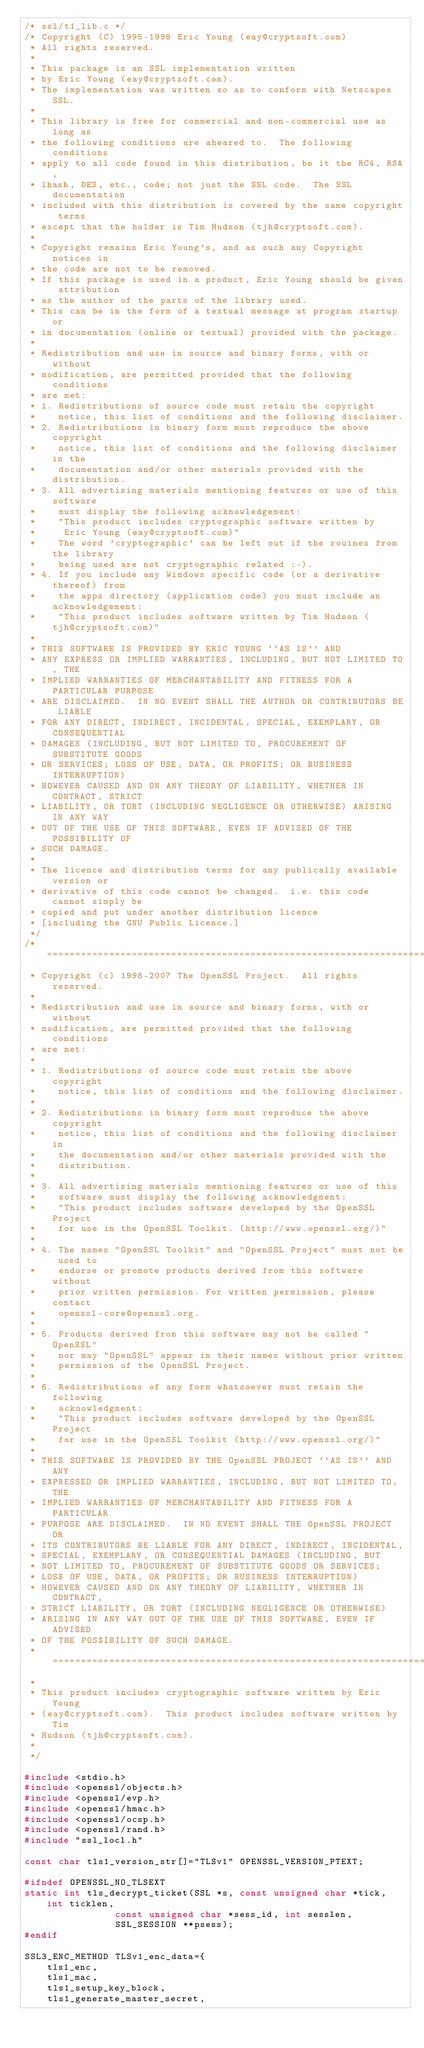Convert code to text. <code><loc_0><loc_0><loc_500><loc_500><_C_>/* ssl/t1_lib.c */
/* Copyright (C) 1995-1998 Eric Young (eay@cryptsoft.com)
 * All rights reserved.
 *
 * This package is an SSL implementation written
 * by Eric Young (eay@cryptsoft.com).
 * The implementation was written so as to conform with Netscapes SSL.
 * 
 * This library is free for commercial and non-commercial use as long as
 * the following conditions are aheared to.  The following conditions
 * apply to all code found in this distribution, be it the RC4, RSA,
 * lhash, DES, etc., code; not just the SSL code.  The SSL documentation
 * included with this distribution is covered by the same copyright terms
 * except that the holder is Tim Hudson (tjh@cryptsoft.com).
 * 
 * Copyright remains Eric Young's, and as such any Copyright notices in
 * the code are not to be removed.
 * If this package is used in a product, Eric Young should be given attribution
 * as the author of the parts of the library used.
 * This can be in the form of a textual message at program startup or
 * in documentation (online or textual) provided with the package.
 * 
 * Redistribution and use in source and binary forms, with or without
 * modification, are permitted provided that the following conditions
 * are met:
 * 1. Redistributions of source code must retain the copyright
 *    notice, this list of conditions and the following disclaimer.
 * 2. Redistributions in binary form must reproduce the above copyright
 *    notice, this list of conditions and the following disclaimer in the
 *    documentation and/or other materials provided with the distribution.
 * 3. All advertising materials mentioning features or use of this software
 *    must display the following acknowledgement:
 *    "This product includes cryptographic software written by
 *     Eric Young (eay@cryptsoft.com)"
 *    The word 'cryptographic' can be left out if the rouines from the library
 *    being used are not cryptographic related :-).
 * 4. If you include any Windows specific code (or a derivative thereof) from 
 *    the apps directory (application code) you must include an acknowledgement:
 *    "This product includes software written by Tim Hudson (tjh@cryptsoft.com)"
 * 
 * THIS SOFTWARE IS PROVIDED BY ERIC YOUNG ``AS IS'' AND
 * ANY EXPRESS OR IMPLIED WARRANTIES, INCLUDING, BUT NOT LIMITED TO, THE
 * IMPLIED WARRANTIES OF MERCHANTABILITY AND FITNESS FOR A PARTICULAR PURPOSE
 * ARE DISCLAIMED.  IN NO EVENT SHALL THE AUTHOR OR CONTRIBUTORS BE LIABLE
 * FOR ANY DIRECT, INDIRECT, INCIDENTAL, SPECIAL, EXEMPLARY, OR CONSEQUENTIAL
 * DAMAGES (INCLUDING, BUT NOT LIMITED TO, PROCUREMENT OF SUBSTITUTE GOODS
 * OR SERVICES; LOSS OF USE, DATA, OR PROFITS; OR BUSINESS INTERRUPTION)
 * HOWEVER CAUSED AND ON ANY THEORY OF LIABILITY, WHETHER IN CONTRACT, STRICT
 * LIABILITY, OR TORT (INCLUDING NEGLIGENCE OR OTHERWISE) ARISING IN ANY WAY
 * OUT OF THE USE OF THIS SOFTWARE, EVEN IF ADVISED OF THE POSSIBILITY OF
 * SUCH DAMAGE.
 * 
 * The licence and distribution terms for any publically available version or
 * derivative of this code cannot be changed.  i.e. this code cannot simply be
 * copied and put under another distribution licence
 * [including the GNU Public Licence.]
 */
/* ====================================================================
 * Copyright (c) 1998-2007 The OpenSSL Project.  All rights reserved.
 *
 * Redistribution and use in source and binary forms, with or without
 * modification, are permitted provided that the following conditions
 * are met:
 *
 * 1. Redistributions of source code must retain the above copyright
 *    notice, this list of conditions and the following disclaimer. 
 *
 * 2. Redistributions in binary form must reproduce the above copyright
 *    notice, this list of conditions and the following disclaimer in
 *    the documentation and/or other materials provided with the
 *    distribution.
 *
 * 3. All advertising materials mentioning features or use of this
 *    software must display the following acknowledgment:
 *    "This product includes software developed by the OpenSSL Project
 *    for use in the OpenSSL Toolkit. (http://www.openssl.org/)"
 *
 * 4. The names "OpenSSL Toolkit" and "OpenSSL Project" must not be used to
 *    endorse or promote products derived from this software without
 *    prior written permission. For written permission, please contact
 *    openssl-core@openssl.org.
 *
 * 5. Products derived from this software may not be called "OpenSSL"
 *    nor may "OpenSSL" appear in their names without prior written
 *    permission of the OpenSSL Project.
 *
 * 6. Redistributions of any form whatsoever must retain the following
 *    acknowledgment:
 *    "This product includes software developed by the OpenSSL Project
 *    for use in the OpenSSL Toolkit (http://www.openssl.org/)"
 *
 * THIS SOFTWARE IS PROVIDED BY THE OpenSSL PROJECT ``AS IS'' AND ANY
 * EXPRESSED OR IMPLIED WARRANTIES, INCLUDING, BUT NOT LIMITED TO, THE
 * IMPLIED WARRANTIES OF MERCHANTABILITY AND FITNESS FOR A PARTICULAR
 * PURPOSE ARE DISCLAIMED.  IN NO EVENT SHALL THE OpenSSL PROJECT OR
 * ITS CONTRIBUTORS BE LIABLE FOR ANY DIRECT, INDIRECT, INCIDENTAL,
 * SPECIAL, EXEMPLARY, OR CONSEQUENTIAL DAMAGES (INCLUDING, BUT
 * NOT LIMITED TO, PROCUREMENT OF SUBSTITUTE GOODS OR SERVICES;
 * LOSS OF USE, DATA, OR PROFITS; OR BUSINESS INTERRUPTION)
 * HOWEVER CAUSED AND ON ANY THEORY OF LIABILITY, WHETHER IN CONTRACT,
 * STRICT LIABILITY, OR TORT (INCLUDING NEGLIGENCE OR OTHERWISE)
 * ARISING IN ANY WAY OUT OF THE USE OF THIS SOFTWARE, EVEN IF ADVISED
 * OF THE POSSIBILITY OF SUCH DAMAGE.
 * ====================================================================
 *
 * This product includes cryptographic software written by Eric Young
 * (eay@cryptsoft.com).  This product includes software written by Tim
 * Hudson (tjh@cryptsoft.com).
 *
 */

#include <stdio.h>
#include <openssl/objects.h>
#include <openssl/evp.h>
#include <openssl/hmac.h>
#include <openssl/ocsp.h>
#include <openssl/rand.h>
#include "ssl_locl.h"

const char tls1_version_str[]="TLSv1" OPENSSL_VERSION_PTEXT;

#ifndef OPENSSL_NO_TLSEXT
static int tls_decrypt_ticket(SSL *s, const unsigned char *tick, int ticklen,
				const unsigned char *sess_id, int sesslen,
				SSL_SESSION **psess);
#endif

SSL3_ENC_METHOD TLSv1_enc_data={
	tls1_enc,
	tls1_mac,
	tls1_setup_key_block,
	tls1_generate_master_secret,</code> 